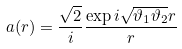<formula> <loc_0><loc_0><loc_500><loc_500>a ( r ) = \frac { \sqrt { 2 } } { i } \frac { \exp { i \sqrt { \vartheta _ { 1 } \vartheta _ { 2 } } r } } { r }</formula> 